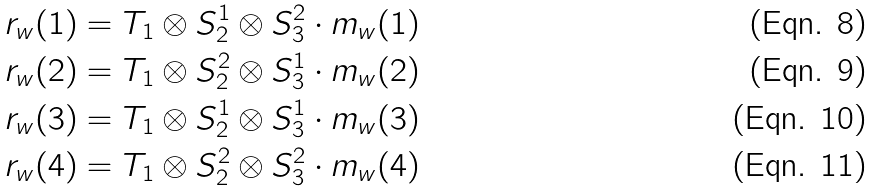<formula> <loc_0><loc_0><loc_500><loc_500>r _ { w } ( 1 ) = T _ { 1 } \otimes S _ { 2 } ^ { 1 } \otimes S _ { 3 } ^ { 2 } \cdot m _ { w } ( 1 ) \\ r _ { w } ( 2 ) = T _ { 1 } \otimes S _ { 2 } ^ { 2 } \otimes S _ { 3 } ^ { 1 } \cdot m _ { w } ( 2 ) \\ r _ { w } ( 3 ) = T _ { 1 } \otimes S _ { 2 } ^ { 1 } \otimes S _ { 3 } ^ { 1 } \cdot m _ { w } ( 3 ) \\ r _ { w } ( 4 ) = T _ { 1 } \otimes S _ { 2 } ^ { 2 } \otimes S _ { 3 } ^ { 2 } \cdot m _ { w } ( 4 )</formula> 